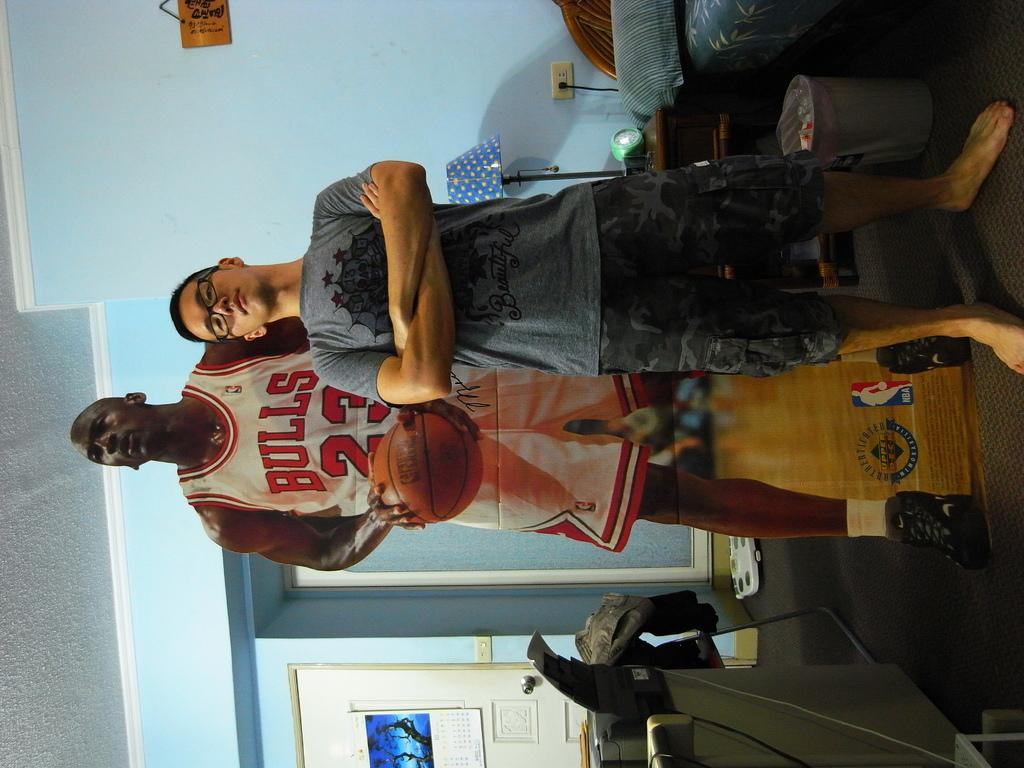<image>
Describe the image concisely. Person standing next to a cardboard basketball player wearing the number 23. 